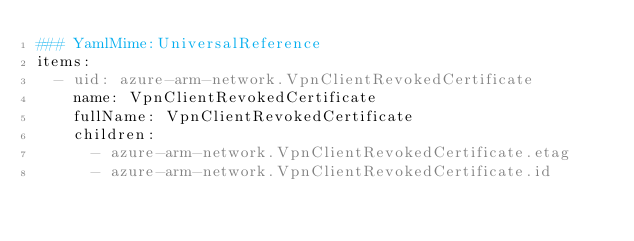<code> <loc_0><loc_0><loc_500><loc_500><_YAML_>### YamlMime:UniversalReference
items:
  - uid: azure-arm-network.VpnClientRevokedCertificate
    name: VpnClientRevokedCertificate
    fullName: VpnClientRevokedCertificate
    children:
      - azure-arm-network.VpnClientRevokedCertificate.etag
      - azure-arm-network.VpnClientRevokedCertificate.id</code> 